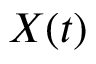Convert formula to latex. <formula><loc_0><loc_0><loc_500><loc_500>X ( t )</formula> 